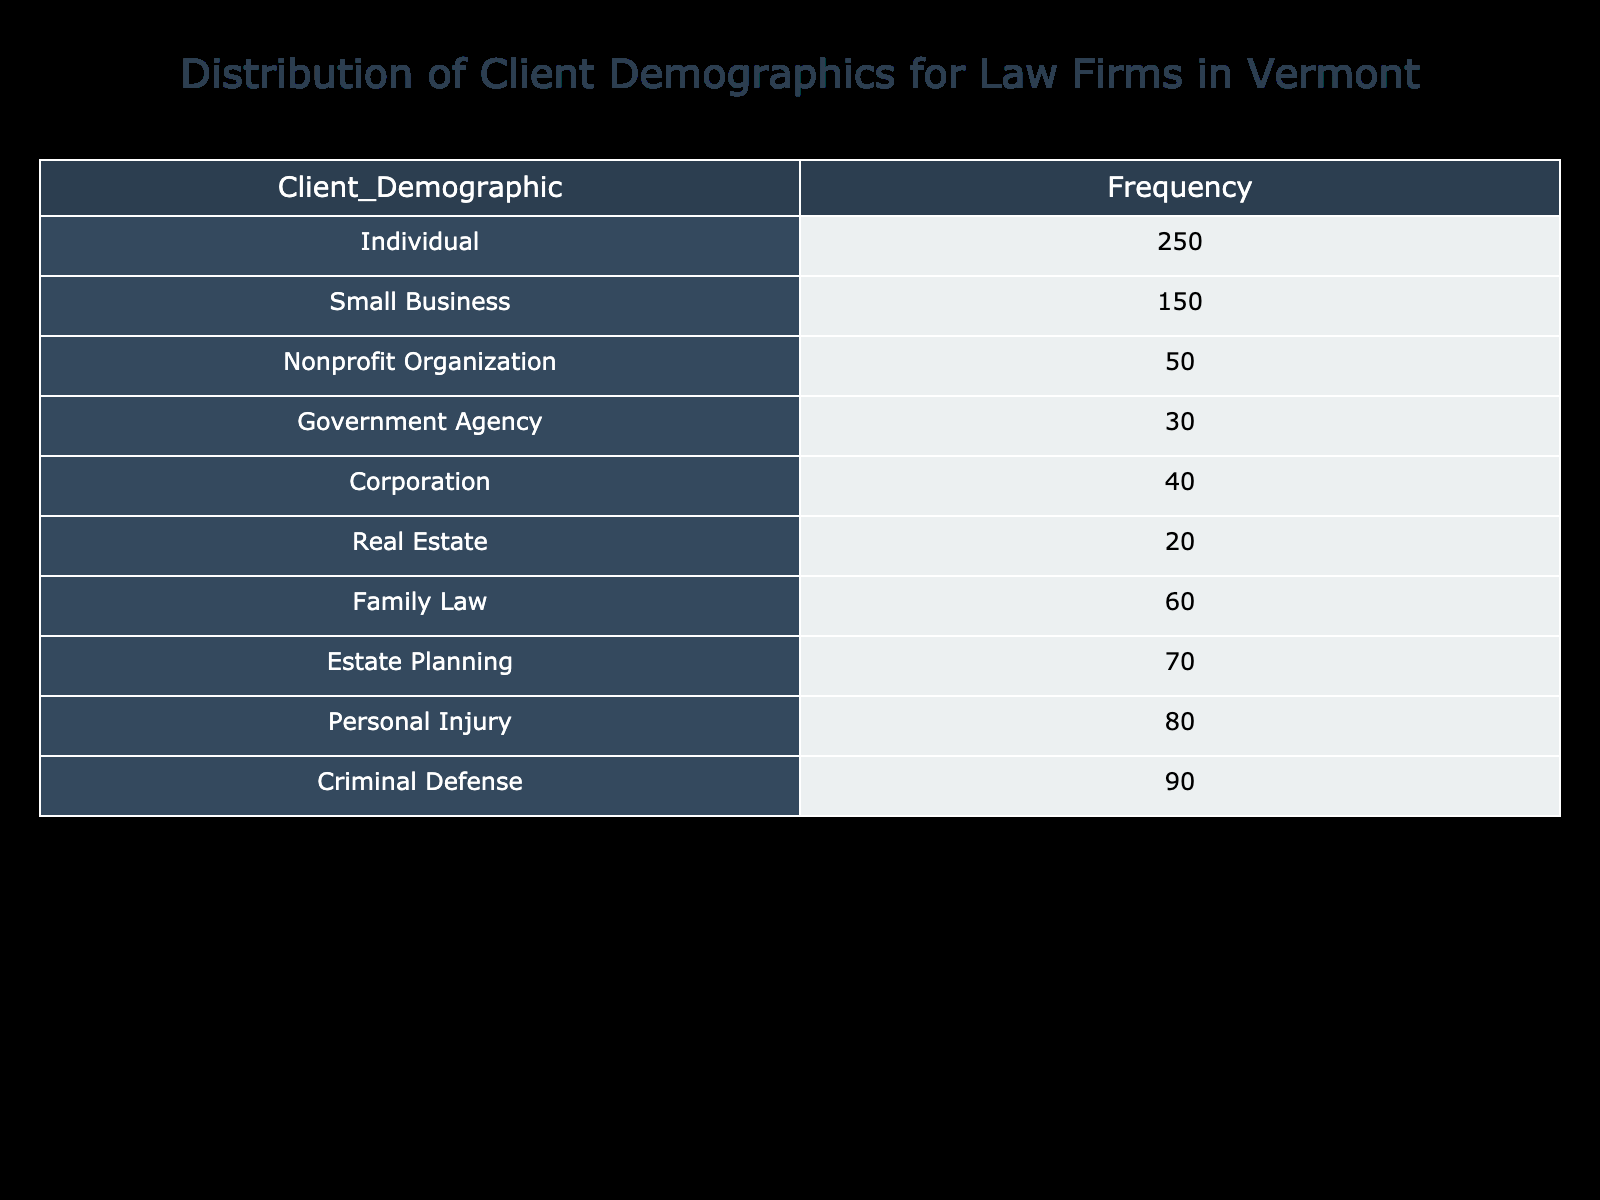What is the frequency of Individual clients? The frequency of Individual clients is explicitly listed in the table under "Frequency". It shows a count of 250 for this demographic.
Answer: 250 How many more clients are registered as Criminal Defense compared to Nonprofit Organizations? To find the difference, we need to subtract the frequency of Nonprofit Organizations (50) from the frequency of Criminal Defense (90). Thus, 90 - 50 = 40.
Answer: 40 Is the frequency of Small Business clients greater than that of Real Estate clients? In the table, Small Business has a frequency of 150 and Real Estate has a frequency of 20. Since 150 is greater than 20, the statement is true.
Answer: Yes What is the total frequency of clients registered under Estate Planning and Personal Injury? The sum of the frequencies for Estate Planning (70) and Personal Injury (80) gives: 70 + 80 = 150.
Answer: 150 Which client demographic has the lowest frequency? By reviewing the frequencies in the table, Real Estate has the lowest frequency listed at 20.
Answer: Real Estate What is the average frequency of client demographics listed in the table? To calculate the average, sum all the frequencies: 250 + 150 + 50 + 30 + 40 + 20 + 60 + 70 + 80 + 90 = 820. Then, divide by the number of demographics (10): 820 / 10 = 82.
Answer: 82 How many client demographics have a frequency of 100 or more? The table lists client demographics with frequencies: 250, 150, 90, and 80. Only Individual and Small Business exceed 100. Therefore, there are 2 demographics.
Answer: 2 What is the combined frequency of Government Agency and Corporation clients? Add the frequencies of Government Agency (30) and Corporation (40): 30 + 40 = 70 to find the combined frequency.
Answer: 70 Is there more than one demographic that has a frequency greater than 80? The demographics with frequencies greater than 80 are Individual (250), Small Business (150), Criminal Defense (90), and Personal Injury (80). Since we find more than one, the answer is true.
Answer: Yes 